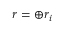<formula> <loc_0><loc_0><loc_500><loc_500>r = \oplus r _ { i }</formula> 